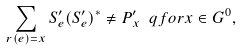Convert formula to latex. <formula><loc_0><loc_0><loc_500><loc_500>\sum _ { r ( e ) = x } S _ { e } ^ { \prime } ( S _ { e } ^ { \prime } ) ^ { * } \neq P _ { x } ^ { \prime } \ q f o r x \in G ^ { 0 } ,</formula> 